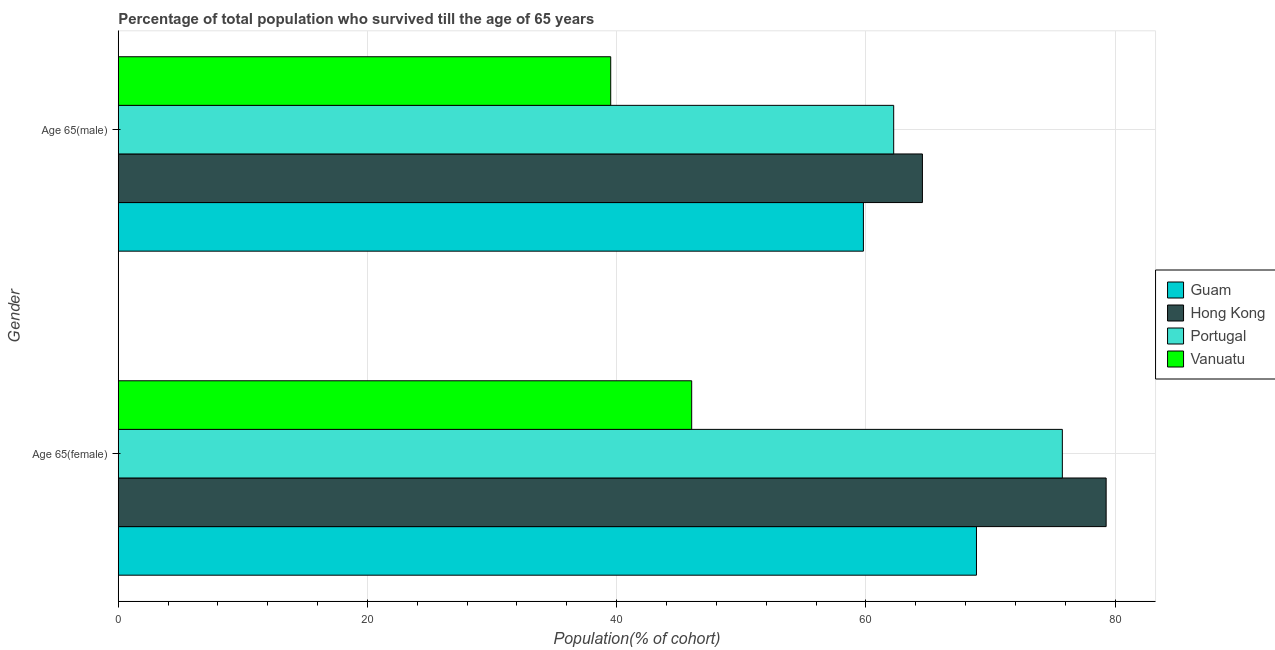How many different coloured bars are there?
Keep it short and to the point. 4. Are the number of bars on each tick of the Y-axis equal?
Provide a succinct answer. Yes. What is the label of the 1st group of bars from the top?
Your answer should be very brief. Age 65(male). What is the percentage of male population who survived till age of 65 in Guam?
Make the answer very short. 59.81. Across all countries, what is the maximum percentage of male population who survived till age of 65?
Your response must be concise. 64.54. Across all countries, what is the minimum percentage of male population who survived till age of 65?
Offer a terse response. 39.52. In which country was the percentage of female population who survived till age of 65 maximum?
Provide a short and direct response. Hong Kong. In which country was the percentage of female population who survived till age of 65 minimum?
Your response must be concise. Vanuatu. What is the total percentage of male population who survived till age of 65 in the graph?
Offer a terse response. 226.11. What is the difference between the percentage of male population who survived till age of 65 in Guam and that in Hong Kong?
Give a very brief answer. -4.74. What is the difference between the percentage of male population who survived till age of 65 in Vanuatu and the percentage of female population who survived till age of 65 in Guam?
Keep it short and to the point. -29.36. What is the average percentage of female population who survived till age of 65 per country?
Keep it short and to the point. 67.49. What is the difference between the percentage of female population who survived till age of 65 and percentage of male population who survived till age of 65 in Hong Kong?
Your answer should be very brief. 14.75. In how many countries, is the percentage of male population who survived till age of 65 greater than 44 %?
Give a very brief answer. 3. What is the ratio of the percentage of male population who survived till age of 65 in Vanuatu to that in Hong Kong?
Your answer should be very brief. 0.61. Is the percentage of female population who survived till age of 65 in Guam less than that in Hong Kong?
Ensure brevity in your answer.  Yes. What does the 3rd bar from the top in Age 65(female) represents?
Offer a terse response. Hong Kong. What does the 1st bar from the bottom in Age 65(female) represents?
Ensure brevity in your answer.  Guam. Are all the bars in the graph horizontal?
Your response must be concise. Yes. How many countries are there in the graph?
Offer a terse response. 4. What is the difference between two consecutive major ticks on the X-axis?
Your answer should be very brief. 20. Are the values on the major ticks of X-axis written in scientific E-notation?
Give a very brief answer. No. Does the graph contain any zero values?
Your answer should be compact. No. Where does the legend appear in the graph?
Provide a short and direct response. Center right. How are the legend labels stacked?
Your answer should be compact. Vertical. What is the title of the graph?
Keep it short and to the point. Percentage of total population who survived till the age of 65 years. Does "Benin" appear as one of the legend labels in the graph?
Offer a very short reply. No. What is the label or title of the X-axis?
Give a very brief answer. Population(% of cohort). What is the label or title of the Y-axis?
Provide a succinct answer. Gender. What is the Population(% of cohort) in Guam in Age 65(female)?
Your answer should be very brief. 68.88. What is the Population(% of cohort) in Hong Kong in Age 65(female)?
Keep it short and to the point. 79.29. What is the Population(% of cohort) of Portugal in Age 65(female)?
Give a very brief answer. 75.77. What is the Population(% of cohort) of Vanuatu in Age 65(female)?
Offer a very short reply. 46.02. What is the Population(% of cohort) of Guam in Age 65(male)?
Make the answer very short. 59.81. What is the Population(% of cohort) of Hong Kong in Age 65(male)?
Your answer should be very brief. 64.54. What is the Population(% of cohort) in Portugal in Age 65(male)?
Provide a short and direct response. 62.24. What is the Population(% of cohort) in Vanuatu in Age 65(male)?
Make the answer very short. 39.52. Across all Gender, what is the maximum Population(% of cohort) in Guam?
Give a very brief answer. 68.88. Across all Gender, what is the maximum Population(% of cohort) of Hong Kong?
Give a very brief answer. 79.29. Across all Gender, what is the maximum Population(% of cohort) of Portugal?
Your answer should be compact. 75.77. Across all Gender, what is the maximum Population(% of cohort) in Vanuatu?
Your response must be concise. 46.02. Across all Gender, what is the minimum Population(% of cohort) of Guam?
Provide a succinct answer. 59.81. Across all Gender, what is the minimum Population(% of cohort) of Hong Kong?
Ensure brevity in your answer.  64.54. Across all Gender, what is the minimum Population(% of cohort) of Portugal?
Ensure brevity in your answer.  62.24. Across all Gender, what is the minimum Population(% of cohort) in Vanuatu?
Your answer should be compact. 39.52. What is the total Population(% of cohort) in Guam in the graph?
Ensure brevity in your answer.  128.69. What is the total Population(% of cohort) of Hong Kong in the graph?
Give a very brief answer. 143.83. What is the total Population(% of cohort) in Portugal in the graph?
Offer a terse response. 138.01. What is the total Population(% of cohort) of Vanuatu in the graph?
Offer a very short reply. 85.55. What is the difference between the Population(% of cohort) of Guam in Age 65(female) and that in Age 65(male)?
Offer a terse response. 9.07. What is the difference between the Population(% of cohort) in Hong Kong in Age 65(female) and that in Age 65(male)?
Make the answer very short. 14.75. What is the difference between the Population(% of cohort) in Portugal in Age 65(female) and that in Age 65(male)?
Make the answer very short. 13.54. What is the difference between the Population(% of cohort) of Vanuatu in Age 65(female) and that in Age 65(male)?
Offer a terse response. 6.5. What is the difference between the Population(% of cohort) in Guam in Age 65(female) and the Population(% of cohort) in Hong Kong in Age 65(male)?
Provide a short and direct response. 4.34. What is the difference between the Population(% of cohort) in Guam in Age 65(female) and the Population(% of cohort) in Portugal in Age 65(male)?
Offer a very short reply. 6.64. What is the difference between the Population(% of cohort) of Guam in Age 65(female) and the Population(% of cohort) of Vanuatu in Age 65(male)?
Offer a terse response. 29.36. What is the difference between the Population(% of cohort) of Hong Kong in Age 65(female) and the Population(% of cohort) of Portugal in Age 65(male)?
Offer a terse response. 17.05. What is the difference between the Population(% of cohort) in Hong Kong in Age 65(female) and the Population(% of cohort) in Vanuatu in Age 65(male)?
Ensure brevity in your answer.  39.77. What is the difference between the Population(% of cohort) of Portugal in Age 65(female) and the Population(% of cohort) of Vanuatu in Age 65(male)?
Provide a succinct answer. 36.25. What is the average Population(% of cohort) of Guam per Gender?
Your response must be concise. 64.34. What is the average Population(% of cohort) in Hong Kong per Gender?
Make the answer very short. 71.92. What is the average Population(% of cohort) of Portugal per Gender?
Your response must be concise. 69. What is the average Population(% of cohort) in Vanuatu per Gender?
Keep it short and to the point. 42.77. What is the difference between the Population(% of cohort) of Guam and Population(% of cohort) of Hong Kong in Age 65(female)?
Ensure brevity in your answer.  -10.41. What is the difference between the Population(% of cohort) in Guam and Population(% of cohort) in Portugal in Age 65(female)?
Keep it short and to the point. -6.89. What is the difference between the Population(% of cohort) of Guam and Population(% of cohort) of Vanuatu in Age 65(female)?
Your response must be concise. 22.86. What is the difference between the Population(% of cohort) in Hong Kong and Population(% of cohort) in Portugal in Age 65(female)?
Keep it short and to the point. 3.52. What is the difference between the Population(% of cohort) in Hong Kong and Population(% of cohort) in Vanuatu in Age 65(female)?
Keep it short and to the point. 33.27. What is the difference between the Population(% of cohort) of Portugal and Population(% of cohort) of Vanuatu in Age 65(female)?
Provide a short and direct response. 29.75. What is the difference between the Population(% of cohort) in Guam and Population(% of cohort) in Hong Kong in Age 65(male)?
Offer a very short reply. -4.74. What is the difference between the Population(% of cohort) of Guam and Population(% of cohort) of Portugal in Age 65(male)?
Your answer should be compact. -2.43. What is the difference between the Population(% of cohort) of Guam and Population(% of cohort) of Vanuatu in Age 65(male)?
Give a very brief answer. 20.28. What is the difference between the Population(% of cohort) in Hong Kong and Population(% of cohort) in Portugal in Age 65(male)?
Your answer should be compact. 2.31. What is the difference between the Population(% of cohort) in Hong Kong and Population(% of cohort) in Vanuatu in Age 65(male)?
Provide a short and direct response. 25.02. What is the difference between the Population(% of cohort) in Portugal and Population(% of cohort) in Vanuatu in Age 65(male)?
Ensure brevity in your answer.  22.71. What is the ratio of the Population(% of cohort) of Guam in Age 65(female) to that in Age 65(male)?
Your response must be concise. 1.15. What is the ratio of the Population(% of cohort) of Hong Kong in Age 65(female) to that in Age 65(male)?
Make the answer very short. 1.23. What is the ratio of the Population(% of cohort) in Portugal in Age 65(female) to that in Age 65(male)?
Your answer should be very brief. 1.22. What is the ratio of the Population(% of cohort) of Vanuatu in Age 65(female) to that in Age 65(male)?
Provide a short and direct response. 1.16. What is the difference between the highest and the second highest Population(% of cohort) of Guam?
Offer a very short reply. 9.07. What is the difference between the highest and the second highest Population(% of cohort) in Hong Kong?
Your answer should be compact. 14.75. What is the difference between the highest and the second highest Population(% of cohort) in Portugal?
Make the answer very short. 13.54. What is the difference between the highest and the second highest Population(% of cohort) in Vanuatu?
Give a very brief answer. 6.5. What is the difference between the highest and the lowest Population(% of cohort) of Guam?
Your answer should be very brief. 9.07. What is the difference between the highest and the lowest Population(% of cohort) in Hong Kong?
Your answer should be very brief. 14.75. What is the difference between the highest and the lowest Population(% of cohort) of Portugal?
Make the answer very short. 13.54. What is the difference between the highest and the lowest Population(% of cohort) in Vanuatu?
Keep it short and to the point. 6.5. 